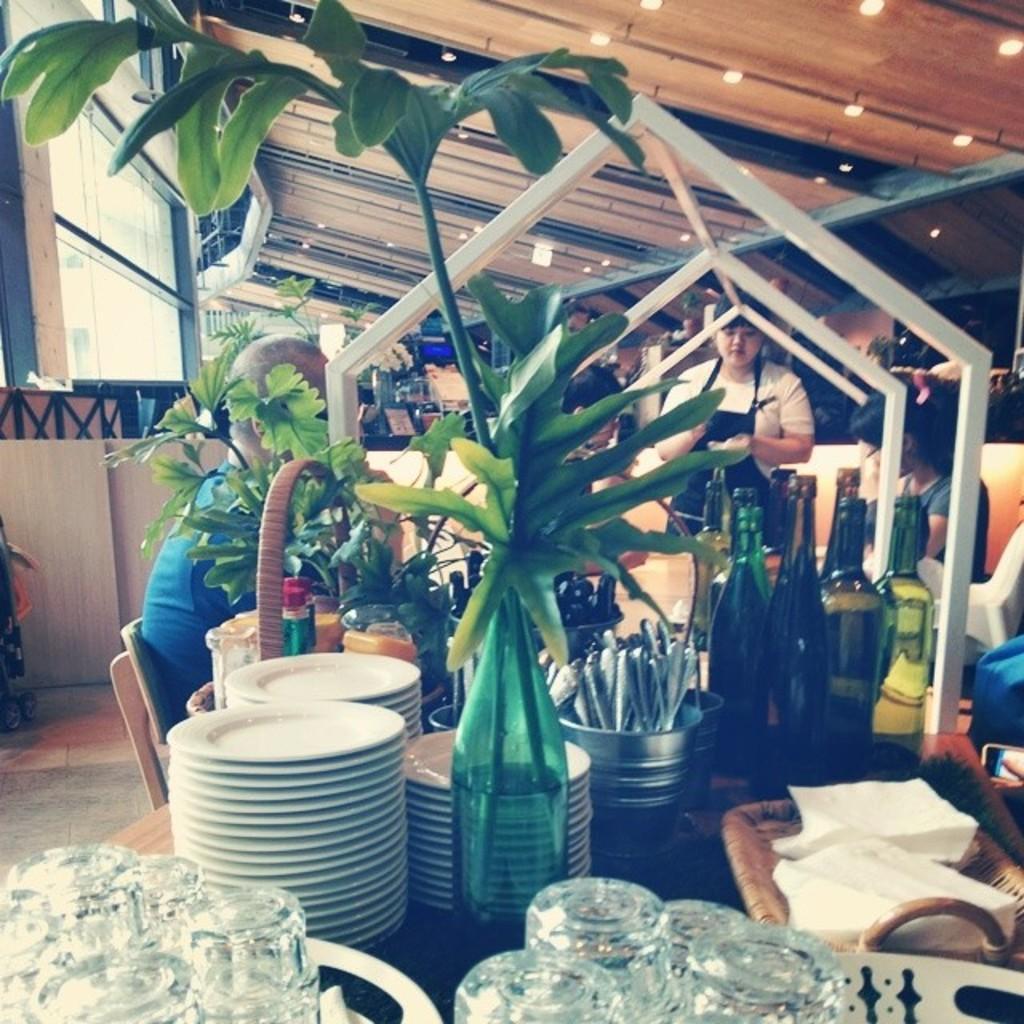Describe this image in one or two sentences. In this image I can see there are plates, glasses and flower vase on this dining table. On the right side there are wine bottles, in the middle a woman is standing, she wore a white color t-shirt. On the left side a man is sitting on the chair, at the top there are ceiling lights. 